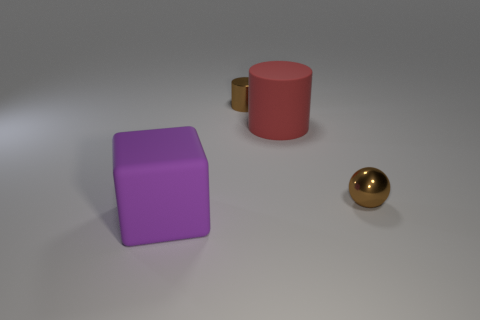Add 4 green metal things. How many objects exist? 8 Subtract all tiny red cubes. Subtract all spheres. How many objects are left? 3 Add 2 big blocks. How many big blocks are left? 3 Add 4 large yellow cubes. How many large yellow cubes exist? 4 Subtract 0 purple spheres. How many objects are left? 4 Subtract all blocks. How many objects are left? 3 